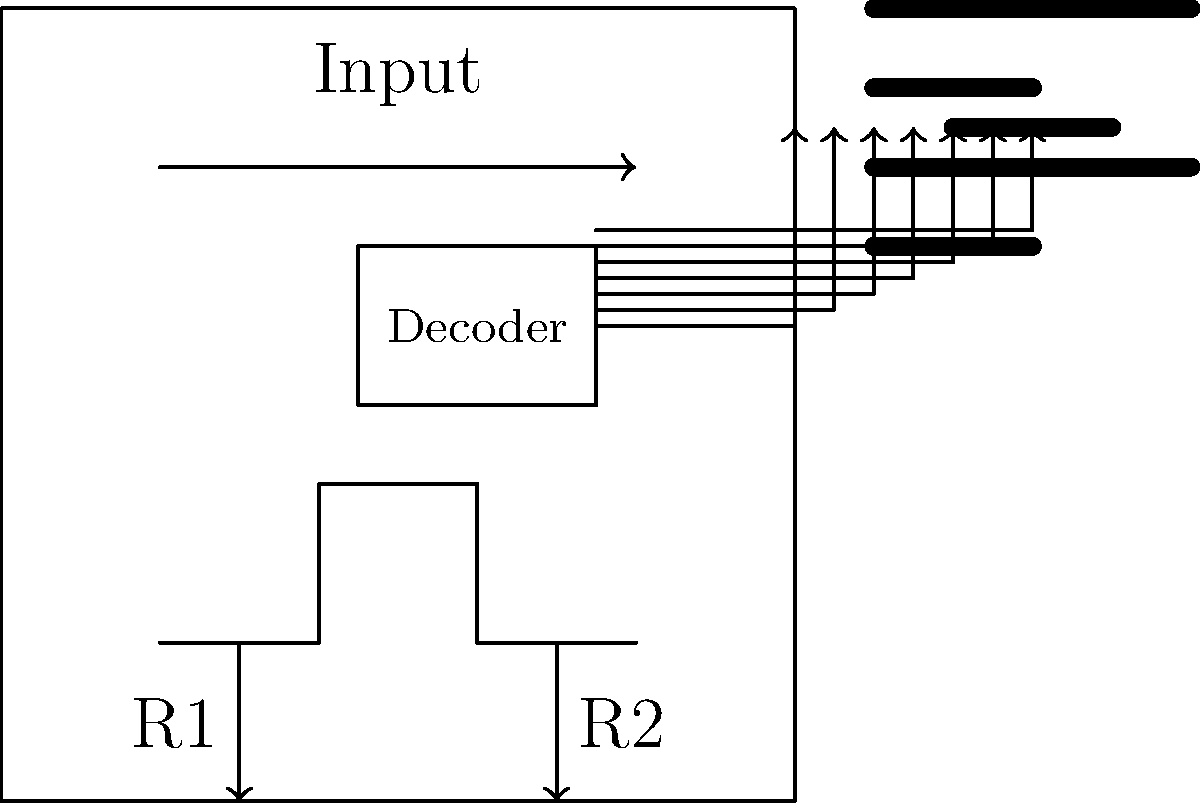You're designing a simple electronic scoreboard for a youth sports event. The circuit uses a 7-segment LED display driven by a decoder. If the input voltage is 5V and each LED segment requires 20mA of current, what should be the approximate values of resistors R1 and R2 to limit the current through each segment? To determine the values of resistors R1 and R2, we need to follow these steps:

1. Understand the circuit: The input voltage is 5V, and each LED segment requires 20mA of current.

2. Determine the voltage drop across an LED segment:
   Typically, an LED has a forward voltage drop of about 2V.

3. Calculate the voltage that needs to be dropped across the resistor:
   $V_R = V_{input} - V_{LED} = 5V - 2V = 3V$

4. Use Ohm's Law to calculate the resistance:
   $R = \frac{V}{I} = \frac{3V}{0.02A} = 150\Omega$

5. Choose a standard resistor value close to the calculated value:
   The closest standard value is 150Ω.

6. Both R1 and R2 serve the same purpose of current limiting for different segments, so they should have the same value.

Therefore, R1 and R2 should both be approximately 150Ω resistors.
Answer: 150Ω 